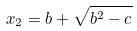Convert formula to latex. <formula><loc_0><loc_0><loc_500><loc_500>x _ { 2 } = b + \sqrt { b ^ { 2 } - c }</formula> 